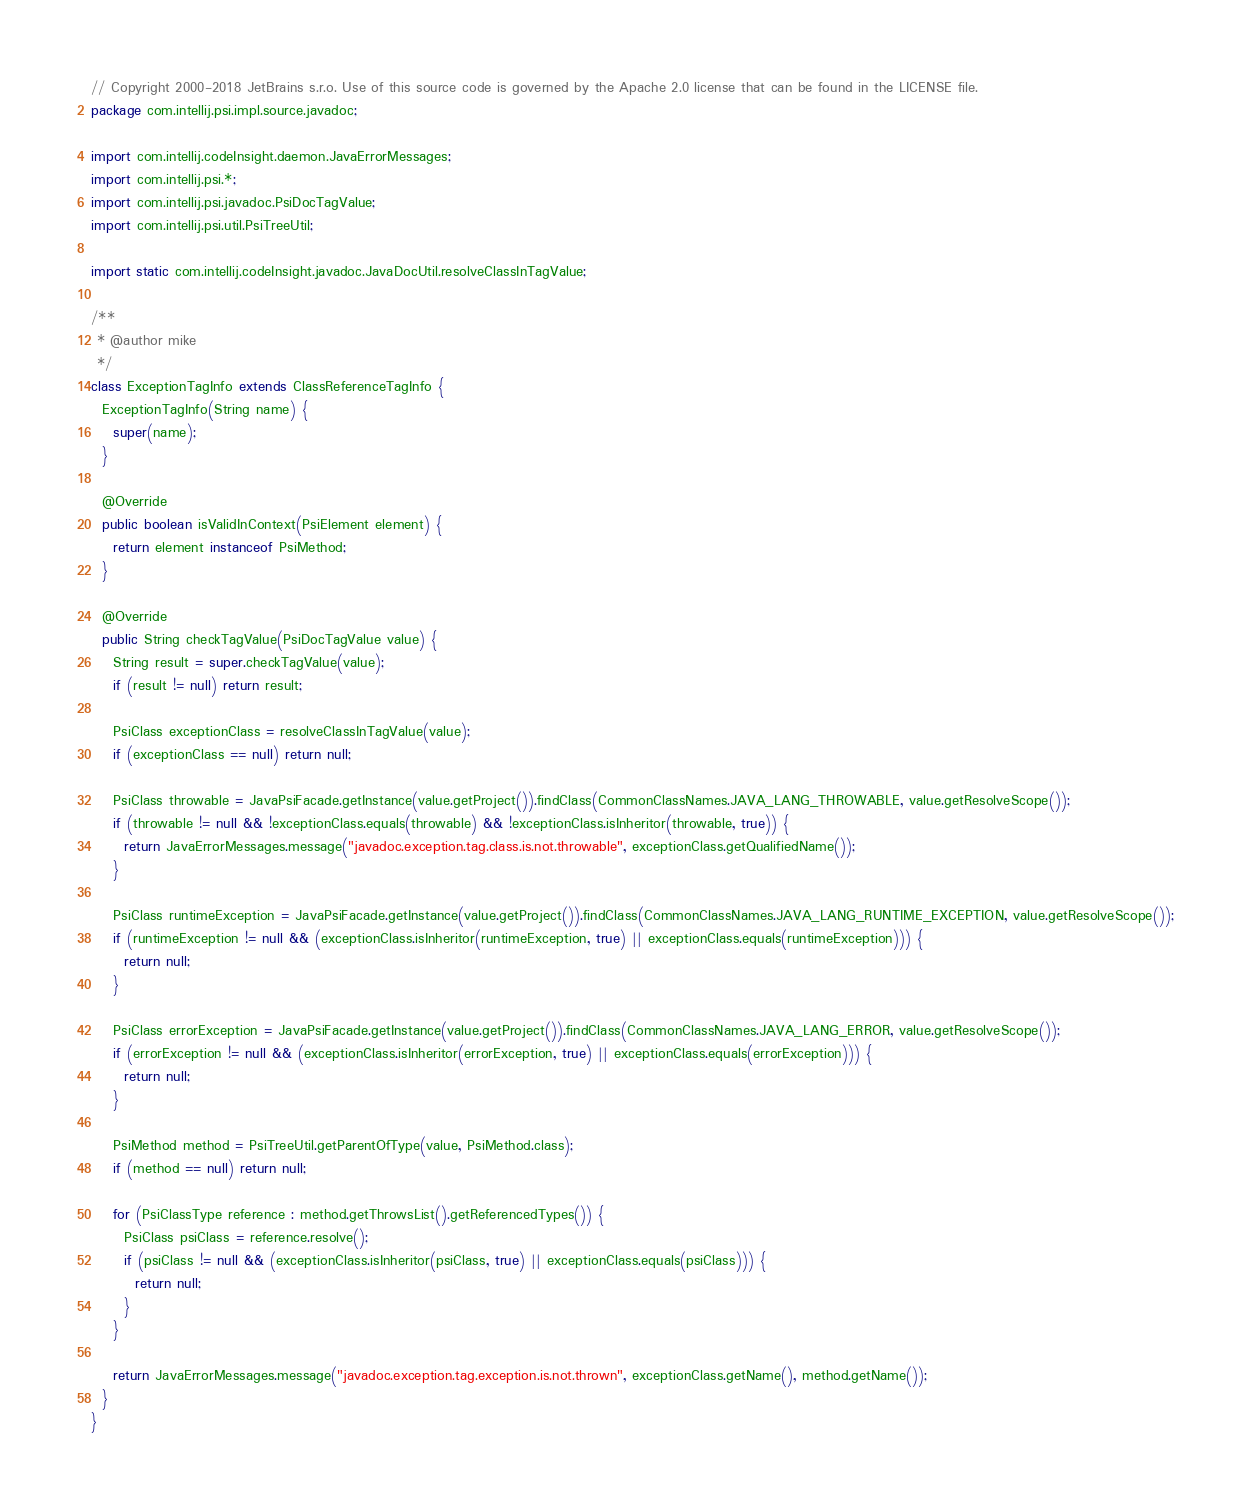Convert code to text. <code><loc_0><loc_0><loc_500><loc_500><_Java_>// Copyright 2000-2018 JetBrains s.r.o. Use of this source code is governed by the Apache 2.0 license that can be found in the LICENSE file.
package com.intellij.psi.impl.source.javadoc;

import com.intellij.codeInsight.daemon.JavaErrorMessages;
import com.intellij.psi.*;
import com.intellij.psi.javadoc.PsiDocTagValue;
import com.intellij.psi.util.PsiTreeUtil;

import static com.intellij.codeInsight.javadoc.JavaDocUtil.resolveClassInTagValue;

/**
 * @author mike
 */
class ExceptionTagInfo extends ClassReferenceTagInfo {
  ExceptionTagInfo(String name) {
    super(name);
  }

  @Override
  public boolean isValidInContext(PsiElement element) {
    return element instanceof PsiMethod;
  }

  @Override
  public String checkTagValue(PsiDocTagValue value) {
    String result = super.checkTagValue(value);
    if (result != null) return result;

    PsiClass exceptionClass = resolveClassInTagValue(value);
    if (exceptionClass == null) return null;

    PsiClass throwable = JavaPsiFacade.getInstance(value.getProject()).findClass(CommonClassNames.JAVA_LANG_THROWABLE, value.getResolveScope());
    if (throwable != null && !exceptionClass.equals(throwable) && !exceptionClass.isInheritor(throwable, true)) {
      return JavaErrorMessages.message("javadoc.exception.tag.class.is.not.throwable", exceptionClass.getQualifiedName());
    }

    PsiClass runtimeException = JavaPsiFacade.getInstance(value.getProject()).findClass(CommonClassNames.JAVA_LANG_RUNTIME_EXCEPTION, value.getResolveScope());
    if (runtimeException != null && (exceptionClass.isInheritor(runtimeException, true) || exceptionClass.equals(runtimeException))) {
      return null;
    }

    PsiClass errorException = JavaPsiFacade.getInstance(value.getProject()).findClass(CommonClassNames.JAVA_LANG_ERROR, value.getResolveScope());
    if (errorException != null && (exceptionClass.isInheritor(errorException, true) || exceptionClass.equals(errorException))) {
      return null;
    }

    PsiMethod method = PsiTreeUtil.getParentOfType(value, PsiMethod.class);
    if (method == null) return null;

    for (PsiClassType reference : method.getThrowsList().getReferencedTypes()) {
      PsiClass psiClass = reference.resolve();
      if (psiClass != null && (exceptionClass.isInheritor(psiClass, true) || exceptionClass.equals(psiClass))) {
        return null;
      }
    }

    return JavaErrorMessages.message("javadoc.exception.tag.exception.is.not.thrown", exceptionClass.getName(), method.getName());
  }
}</code> 